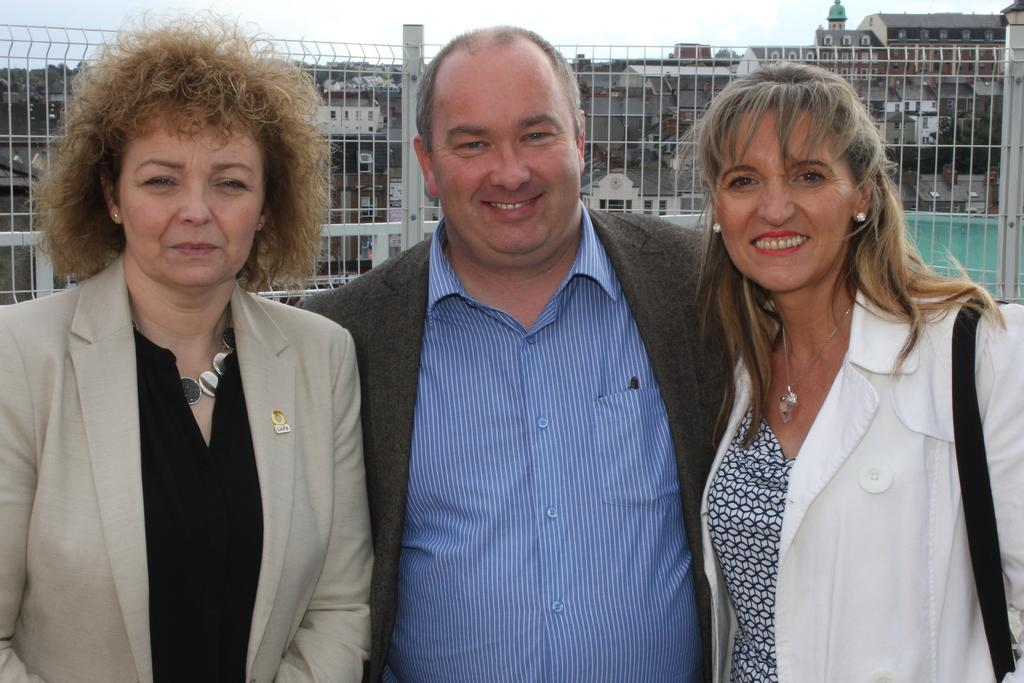How many people are in the image? There are three people in the image: a man and two women. What are the people in the image doing? The man and women are standing together and smiling. What can be seen in the background of the image? There are buildings and the sky visible in the background of the image. What type of grass is growing on the stove in the image? There is no grass or stove present in the image. 